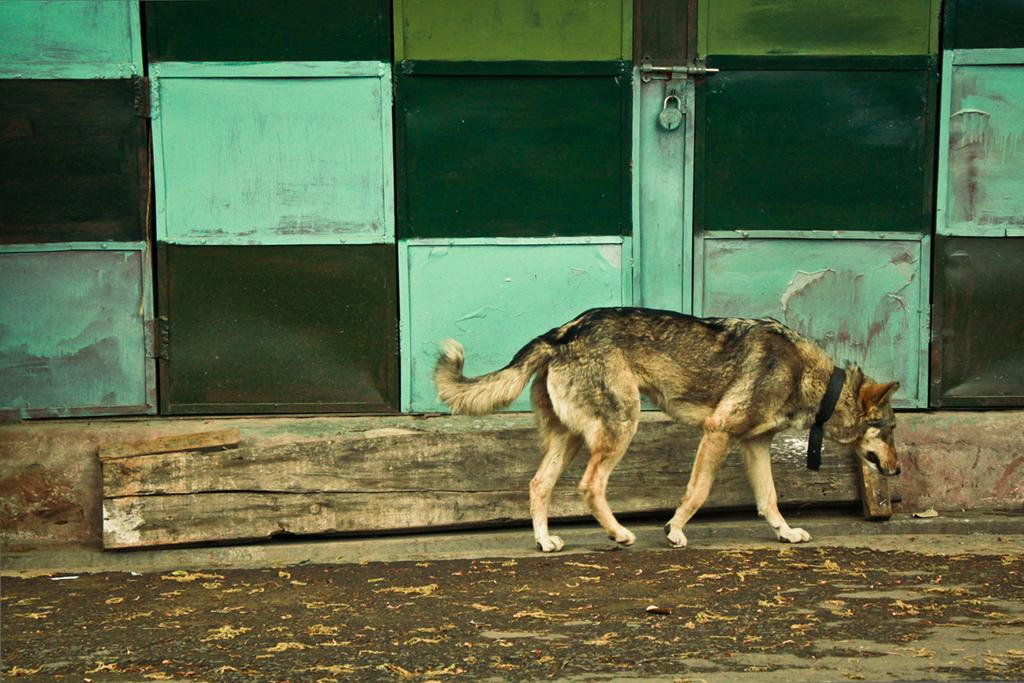What type of animal is in the image? There is a dog in the image. What is the dog doing in the image? The dog is walking. What can be seen in the background of the image? There is a green and blue door in the background of the image. What feature is present on the door? There is a lock on the door. What type of skate is the dog using to move around in the image? There is no skate present in the image; the dog is walking on its own. Is the dog in the image a spy? There is no indication in the image that the dog is a spy, as it is simply walking. 